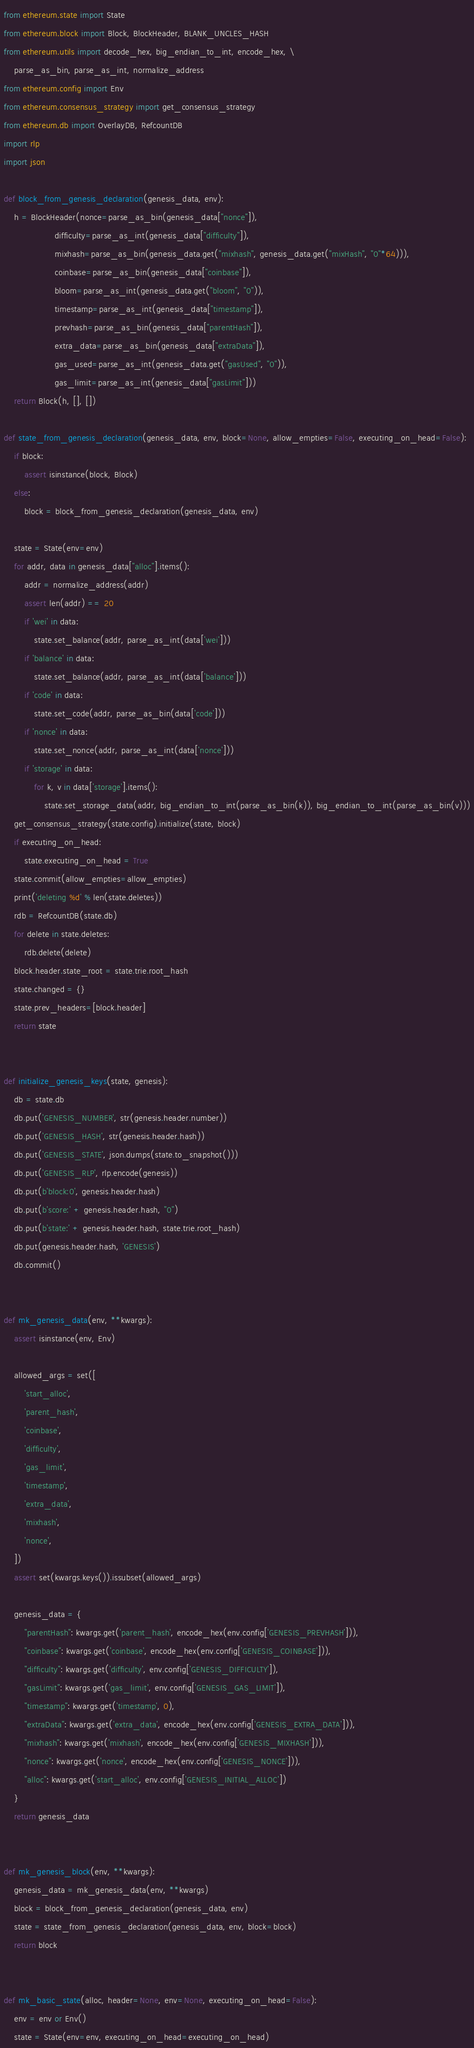<code> <loc_0><loc_0><loc_500><loc_500><_Python_>from ethereum.state import State
from ethereum.block import Block, BlockHeader, BLANK_UNCLES_HASH
from ethereum.utils import decode_hex, big_endian_to_int, encode_hex, \
    parse_as_bin, parse_as_int, normalize_address
from ethereum.config import Env
from ethereum.consensus_strategy import get_consensus_strategy
from ethereum.db import OverlayDB, RefcountDB
import rlp
import json

def block_from_genesis_declaration(genesis_data, env):
    h = BlockHeader(nonce=parse_as_bin(genesis_data["nonce"]),
                    difficulty=parse_as_int(genesis_data["difficulty"]),
                    mixhash=parse_as_bin(genesis_data.get("mixhash", genesis_data.get("mixHash", "0"*64))),
                    coinbase=parse_as_bin(genesis_data["coinbase"]),
                    bloom=parse_as_int(genesis_data.get("bloom", "0")),
                    timestamp=parse_as_int(genesis_data["timestamp"]),
                    prevhash=parse_as_bin(genesis_data["parentHash"]),
                    extra_data=parse_as_bin(genesis_data["extraData"]),
                    gas_used=parse_as_int(genesis_data.get("gasUsed", "0")),
                    gas_limit=parse_as_int(genesis_data["gasLimit"]))
    return Block(h, [], [])

def state_from_genesis_declaration(genesis_data, env, block=None, allow_empties=False, executing_on_head=False):
    if block:
        assert isinstance(block, Block)
    else:
        block = block_from_genesis_declaration(genesis_data, env)

    state = State(env=env)
    for addr, data in genesis_data["alloc"].items():
        addr = normalize_address(addr)
        assert len(addr) == 20
        if 'wei' in data:
            state.set_balance(addr, parse_as_int(data['wei']))
        if 'balance' in data:
            state.set_balance(addr, parse_as_int(data['balance']))
        if 'code' in data:
            state.set_code(addr, parse_as_bin(data['code']))
        if 'nonce' in data:
            state.set_nonce(addr, parse_as_int(data['nonce']))
        if 'storage' in data:
            for k, v in data['storage'].items():
                state.set_storage_data(addr, big_endian_to_int(parse_as_bin(k)), big_endian_to_int(parse_as_bin(v)))
    get_consensus_strategy(state.config).initialize(state, block)
    if executing_on_head:
        state.executing_on_head = True
    state.commit(allow_empties=allow_empties)
    print('deleting %d' % len(state.deletes))
    rdb = RefcountDB(state.db)
    for delete in state.deletes:
        rdb.delete(delete)
    block.header.state_root = state.trie.root_hash
    state.changed = {}
    state.prev_headers=[block.header]
    return state


def initialize_genesis_keys(state, genesis):
    db = state.db
    db.put('GENESIS_NUMBER', str(genesis.header.number))
    db.put('GENESIS_HASH', str(genesis.header.hash))
    db.put('GENESIS_STATE', json.dumps(state.to_snapshot()))
    db.put('GENESIS_RLP', rlp.encode(genesis))
    db.put(b'block:0', genesis.header.hash)
    db.put(b'score:' + genesis.header.hash, "0")
    db.put(b'state:' + genesis.header.hash, state.trie.root_hash)
    db.put(genesis.header.hash, 'GENESIS')
    db.commit()


def mk_genesis_data(env, **kwargs):
    assert isinstance(env, Env)

    allowed_args = set([
        'start_alloc',
        'parent_hash',
        'coinbase',
        'difficulty',
        'gas_limit',
        'timestamp',
        'extra_data',
        'mixhash',
        'nonce',
    ])
    assert set(kwargs.keys()).issubset(allowed_args)

    genesis_data = {
        "parentHash": kwargs.get('parent_hash', encode_hex(env.config['GENESIS_PREVHASH'])),
        "coinbase": kwargs.get('coinbase', encode_hex(env.config['GENESIS_COINBASE'])),
        "difficulty": kwargs.get('difficulty', env.config['GENESIS_DIFFICULTY']),
        "gasLimit": kwargs.get('gas_limit', env.config['GENESIS_GAS_LIMIT']),
        "timestamp": kwargs.get('timestamp', 0),
        "extraData": kwargs.get('extra_data', encode_hex(env.config['GENESIS_EXTRA_DATA'])),
        "mixhash": kwargs.get('mixhash', encode_hex(env.config['GENESIS_MIXHASH'])),
        "nonce": kwargs.get('nonce', encode_hex(env.config['GENESIS_NONCE'])),
        "alloc": kwargs.get('start_alloc', env.config['GENESIS_INITIAL_ALLOC'])
    }
    return genesis_data


def mk_genesis_block(env, **kwargs):
    genesis_data = mk_genesis_data(env, **kwargs)
    block = block_from_genesis_declaration(genesis_data, env)
    state = state_from_genesis_declaration(genesis_data, env, block=block)
    return block


def mk_basic_state(alloc, header=None, env=None, executing_on_head=False):
    env = env or Env()
    state = State(env=env, executing_on_head=executing_on_head)</code> 